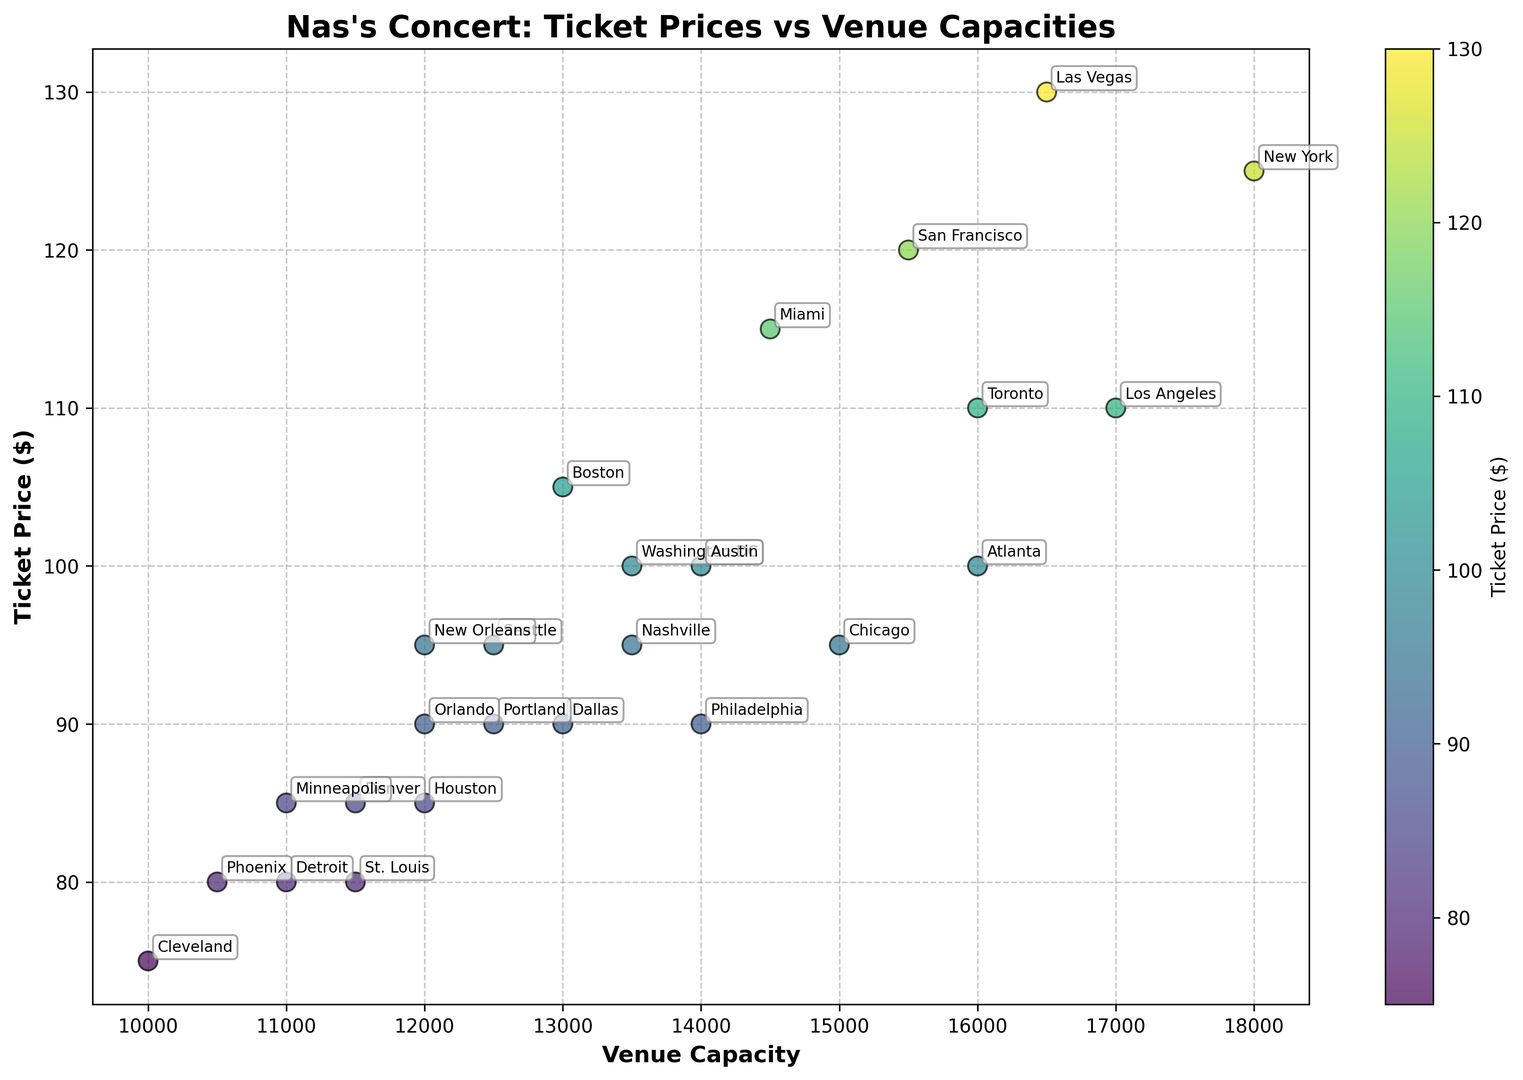How much is the ticket price difference between the most expensive and the least expensive venue? The most expensive ticket price is $130 (Las Vegas), and the least expensive ticket price is $75 (Cleveland). The difference is $130 - $75 = $55.
Answer: $55 Which city has the highest venue capacity, and what is the ticket price there? The highest venue capacity is in New York with 18,000 seats, and the ticket price there is $125.
Answer: New York, $125 Are there any cities with the same venue capacity but different ticket prices? Yes, two cities have a venue capacity of 12,000: Houston with a ticket price of $85 and New Orleans with a ticket price of $95.
Answer: Yes, Houston and New Orleans Is there a trend between venue capacity and ticket price? Observing the plot, there is no clear trend suggesting a direct correlation between venue capacity and ticket price.
Answer: No clear trend Which city has the lowest ticket price and what is its venue capacity? The lowest ticket price is $75 in Cleveland, and its venue capacity is 10,000.
Answer: Cleveland, 10,000 What is the average ticket price for venues with a capacity greater than 15,000? The cities with venue capacity greater than 15,000 are New York, Los Angeles, Atlanta, Las Vegas, San Francisco, and Toronto. Their ticket prices are 125, 110, 100, 130, 120, and 110 respectively. The average ticket price is (125 + 110 + 100 + 130 + 120 + 110) / 6 = 695 / 6 = $115.83.
Answer: $115.83 Among the cities with a ticket price of $100, which one has the largest venue capacity? Cities with a ticket price of $100 are Atlanta, Washington DC, and Austin. Their capacities are 16,000, 13,500, and 14,000 respectively. The largest capacity among them is Atlanta with 16,000.
Answer: Atlanta Which city with a venue capacity of less than 15,000 has the highest ticket price? Among cities with a venue capacity of less than 15,000, San Francisco has the highest ticket price of $120 with a capacity of 15,500 (excluded). Boston has the highest ticket price with a capacity of less than 15,000 at $105.
Answer: Boston 